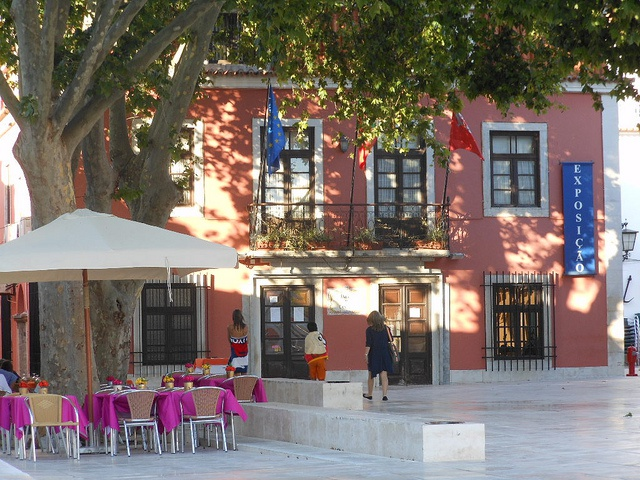Describe the objects in this image and their specific colors. I can see umbrella in darkgreen, lightgray, darkgray, and gray tones, chair in darkgreen, tan, darkgray, purple, and gray tones, chair in darkgreen, gray, purple, and darkgray tones, people in darkgreen, black, gray, and darkgray tones, and chair in darkgreen, gray, purple, and darkgray tones in this image. 